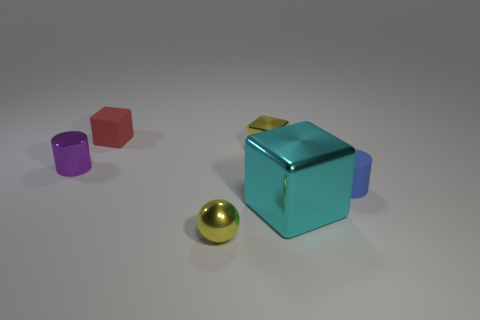Subtract all tiny cubes. How many cubes are left? 1 Add 3 yellow spheres. How many objects exist? 9 Subtract all spheres. How many objects are left? 5 Subtract all tiny green matte balls. Subtract all small yellow objects. How many objects are left? 4 Add 3 tiny yellow spheres. How many tiny yellow spheres are left? 4 Add 1 green metal balls. How many green metal balls exist? 1 Subtract 0 brown balls. How many objects are left? 6 